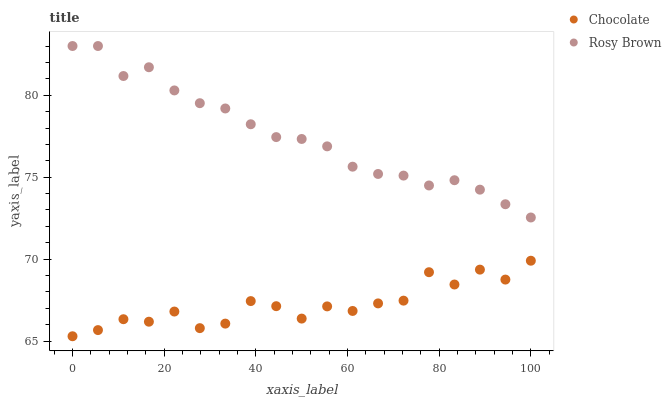Does Chocolate have the minimum area under the curve?
Answer yes or no. Yes. Does Rosy Brown have the maximum area under the curve?
Answer yes or no. Yes. Does Chocolate have the maximum area under the curve?
Answer yes or no. No. Is Rosy Brown the smoothest?
Answer yes or no. Yes. Is Chocolate the roughest?
Answer yes or no. Yes. Is Chocolate the smoothest?
Answer yes or no. No. Does Chocolate have the lowest value?
Answer yes or no. Yes. Does Rosy Brown have the highest value?
Answer yes or no. Yes. Does Chocolate have the highest value?
Answer yes or no. No. Is Chocolate less than Rosy Brown?
Answer yes or no. Yes. Is Rosy Brown greater than Chocolate?
Answer yes or no. Yes. Does Chocolate intersect Rosy Brown?
Answer yes or no. No. 